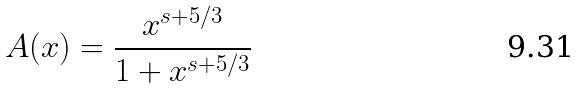<formula> <loc_0><loc_0><loc_500><loc_500>A ( x ) = \frac { { x ^ { s + 5 / 3 } } } { 1 + x ^ { s + 5 / 3 } }</formula> 